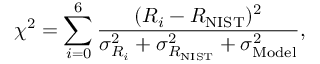Convert formula to latex. <formula><loc_0><loc_0><loc_500><loc_500>\chi ^ { 2 } = \sum _ { i = 0 } ^ { 6 } \frac { ( R _ { i } - R _ { N I S T } ) ^ { 2 } } { \sigma _ { R _ { i } } ^ { 2 } + \sigma _ { { R _ { N I S T } } } ^ { 2 } + \sigma _ { M o d e l } ^ { 2 } } ,</formula> 